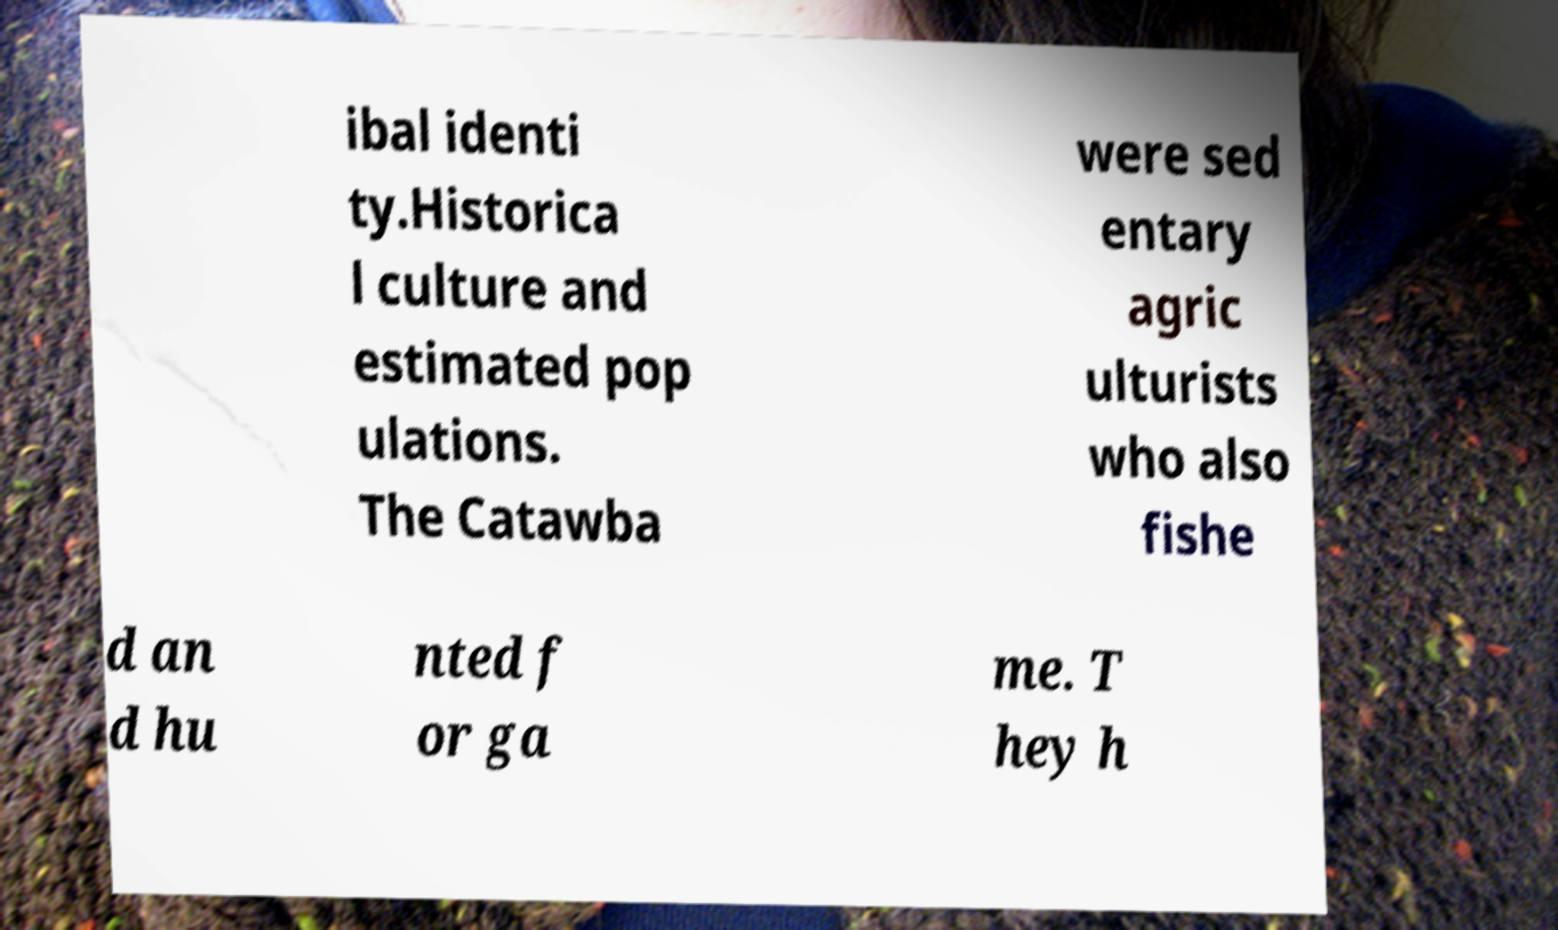What messages or text are displayed in this image? I need them in a readable, typed format. ibal identi ty.Historica l culture and estimated pop ulations. The Catawba were sed entary agric ulturists who also fishe d an d hu nted f or ga me. T hey h 